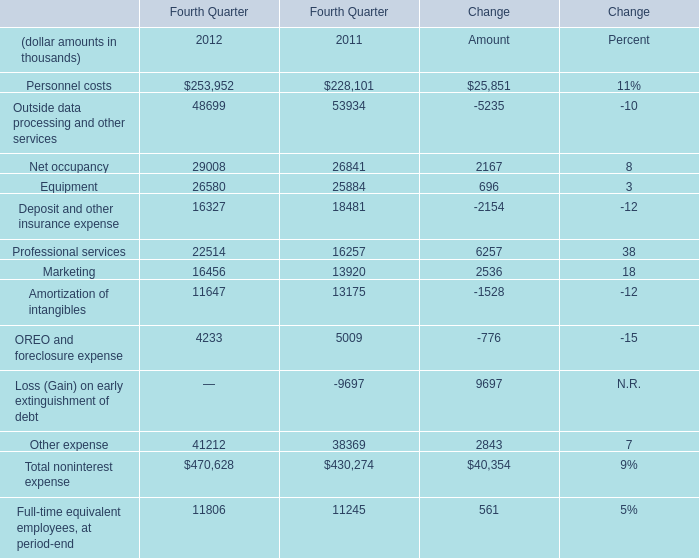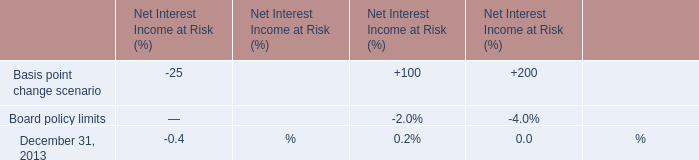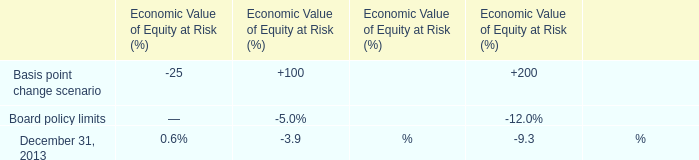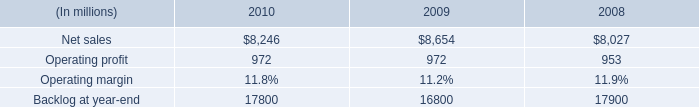What's the sum of Amortization of intangibles of Fourth Quarter 2011, Net sales of 2008, and Total noninterest expense of Change Amount ? 
Computations: ((13175.0 + 8027.0) + 40354.0)
Answer: 61556.0. 